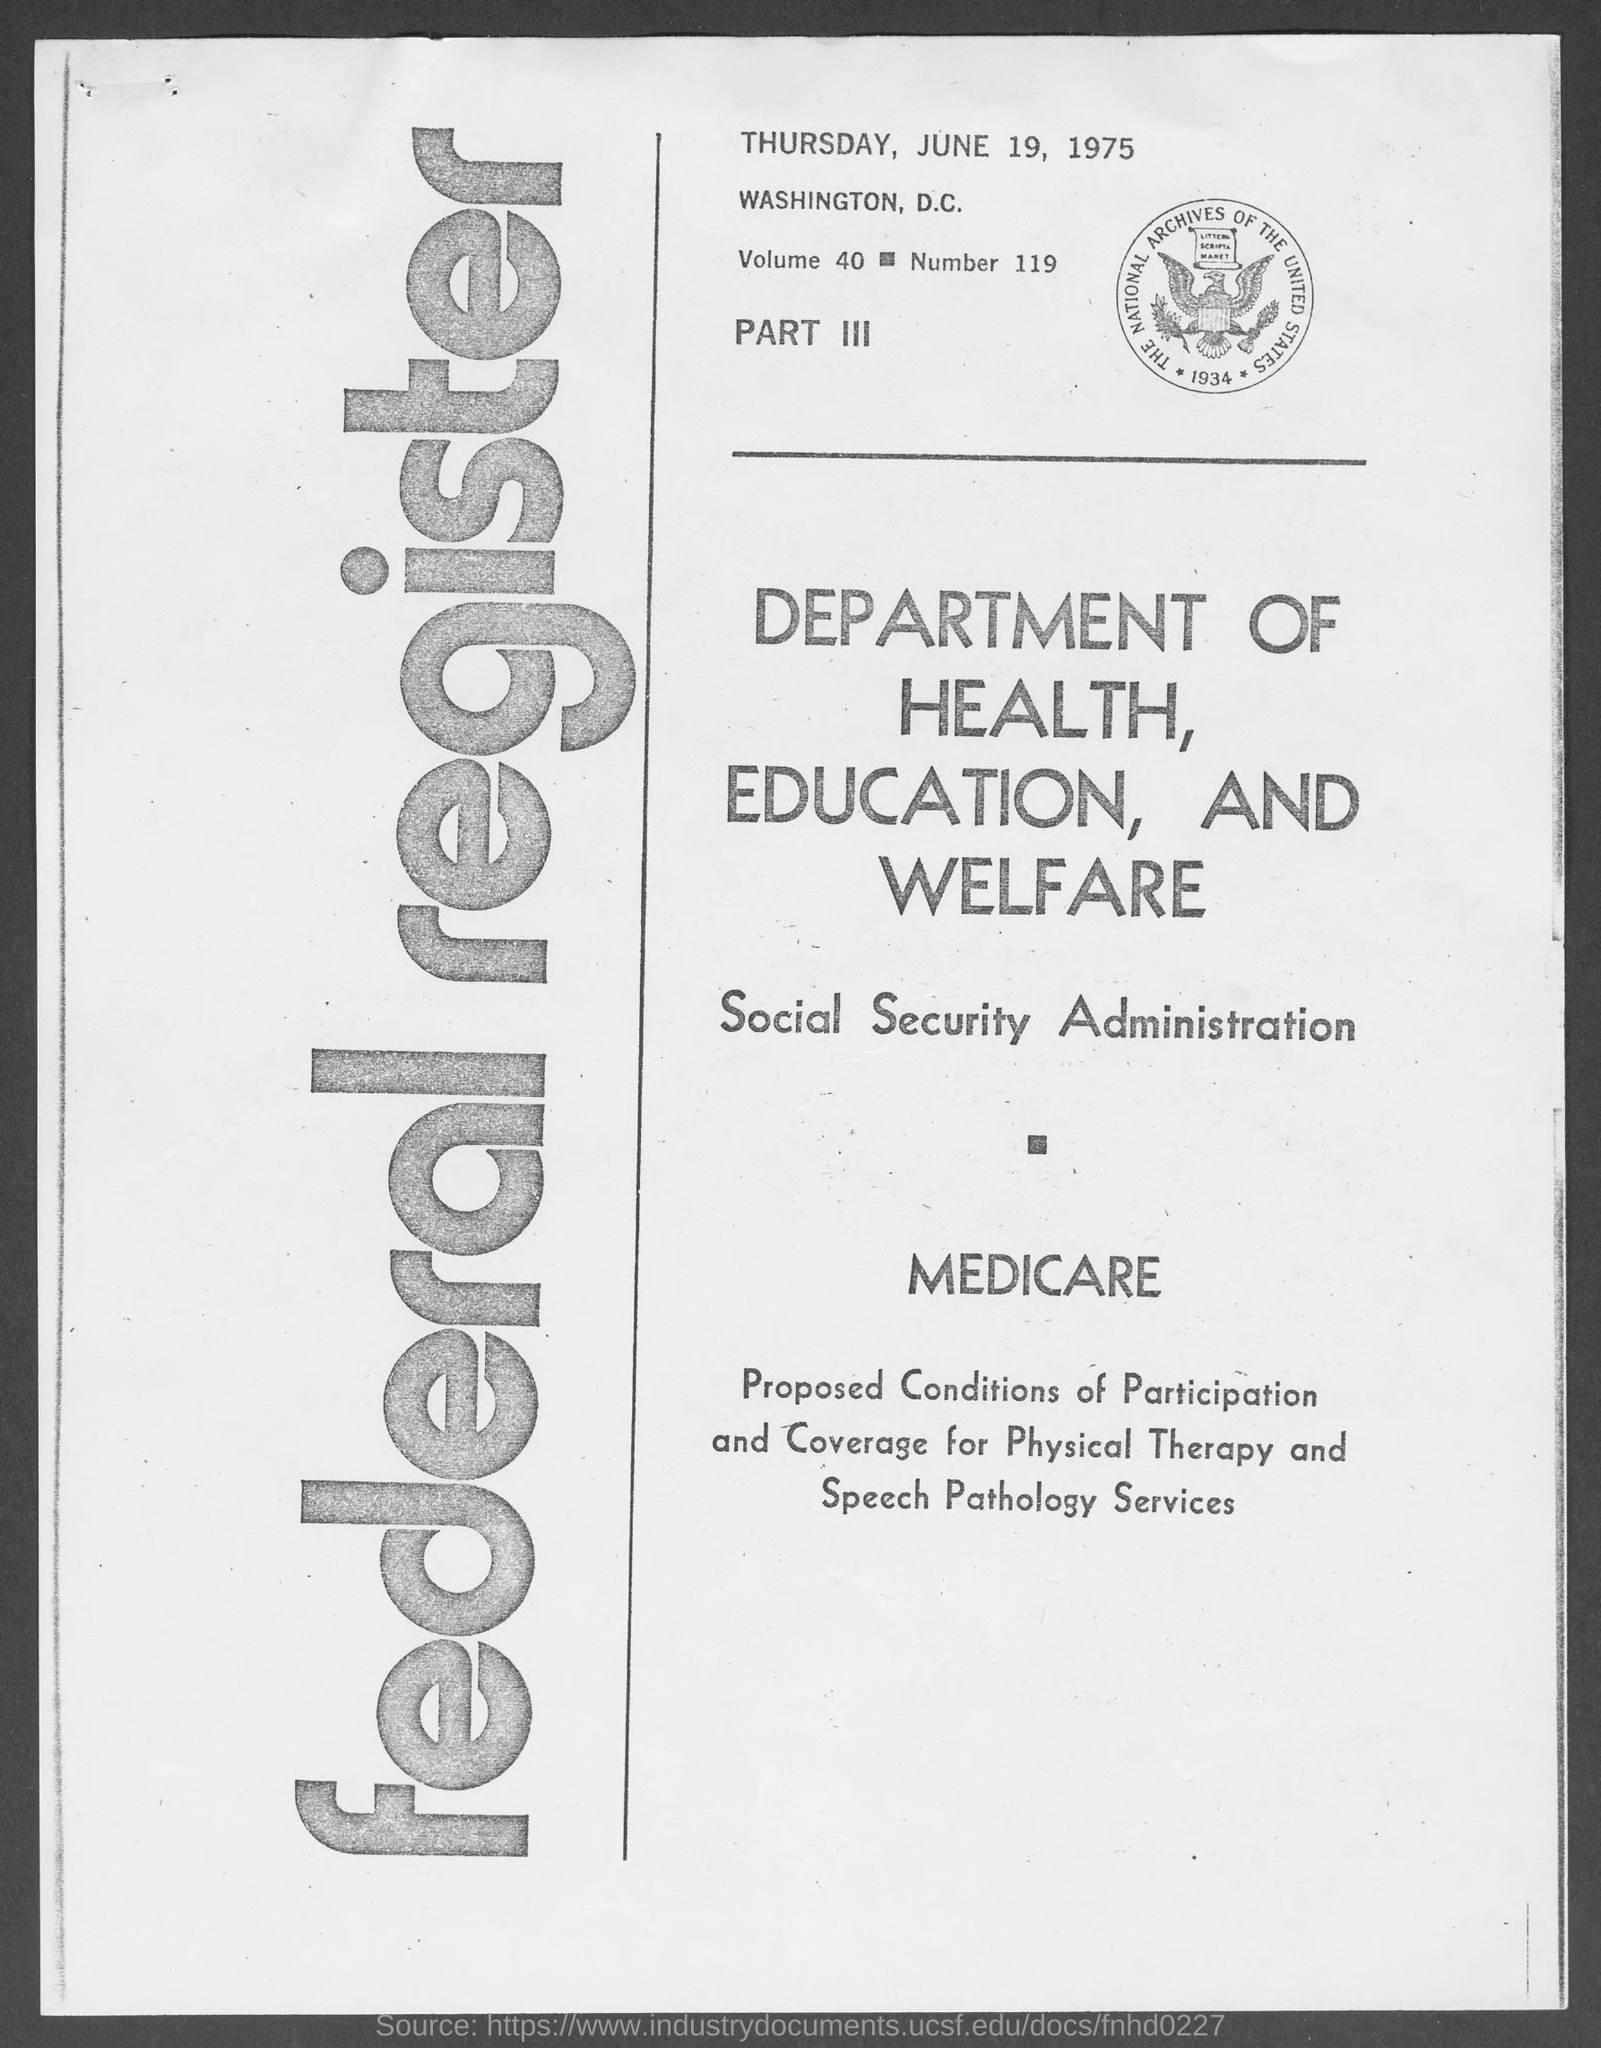What day of the week is mentioned at top of the page?
Provide a short and direct response. THURSDAY. 